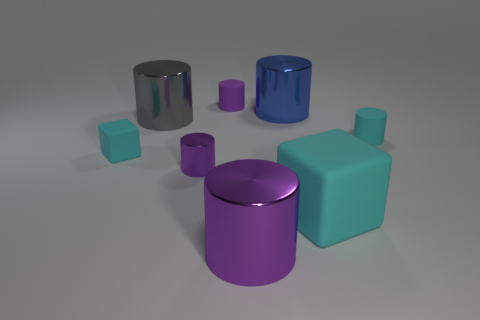Subtract all big gray metal cylinders. How many cylinders are left? 5 Add 1 purple rubber cylinders. How many objects exist? 9 Subtract all cyan cylinders. How many cylinders are left? 5 Subtract all cubes. How many objects are left? 6 Subtract all cyan cubes. How many purple cylinders are left? 3 Add 8 purple shiny cylinders. How many purple shiny cylinders are left? 10 Add 2 tiny purple matte objects. How many tiny purple matte objects exist? 3 Subtract 0 green cubes. How many objects are left? 8 Subtract 4 cylinders. How many cylinders are left? 2 Subtract all purple cubes. Subtract all purple cylinders. How many cubes are left? 2 